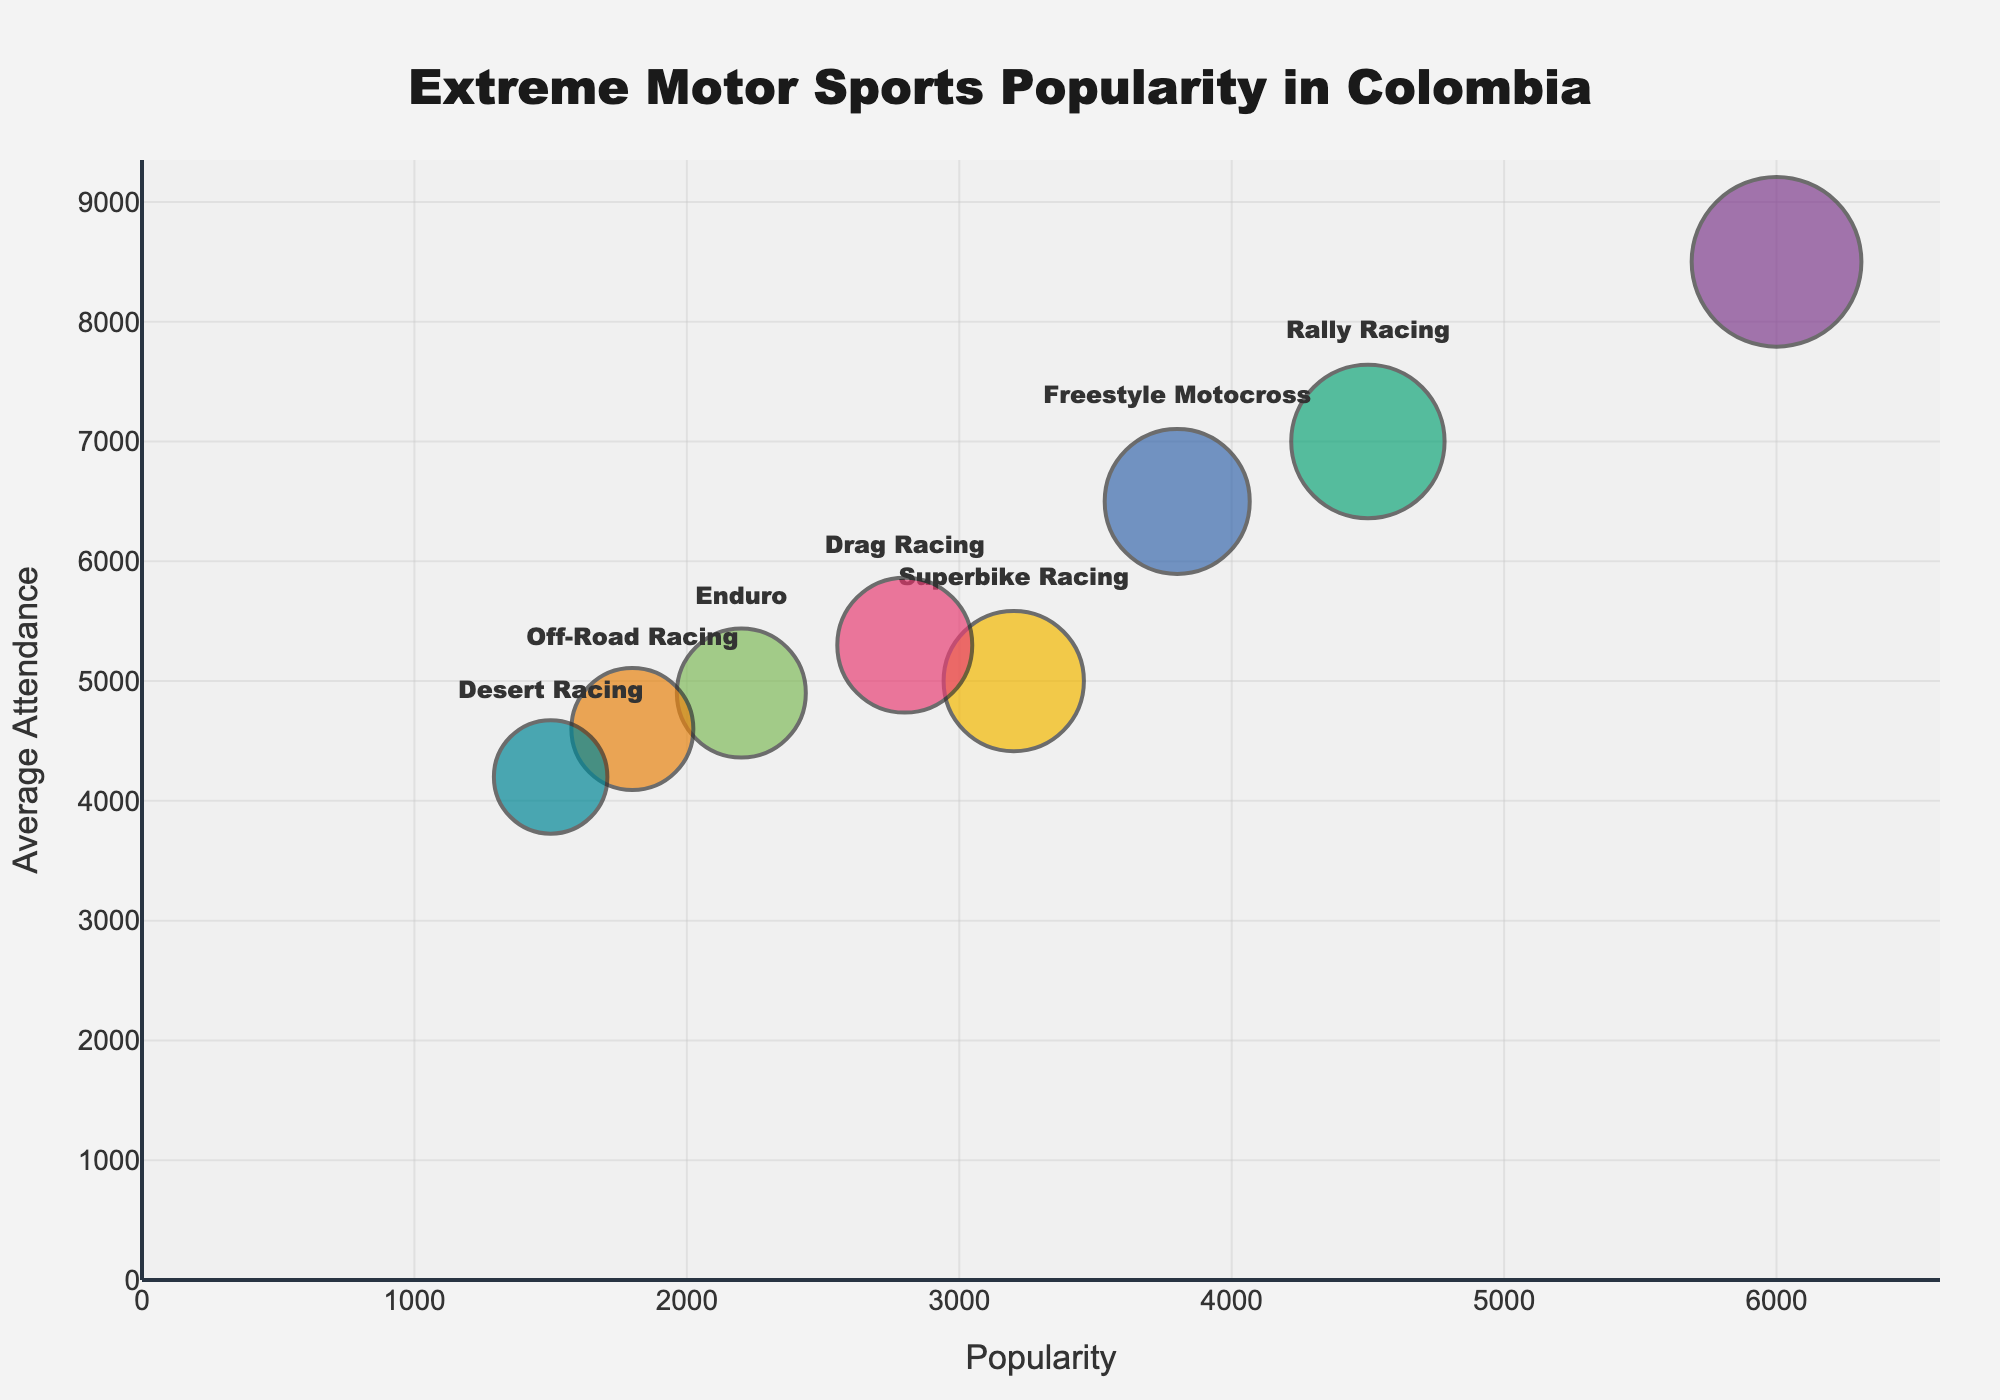What is the title of the Bubble Chart? The title of the Bubble Chart is displayed prominently at the top center of the figure. It reads "Extreme Motor Sports Popularity in Colombia".
Answer: Extreme Motor Sports Popularity in Colombia Which motorsport in Bogota has the highest popularity? The figure shows that the motorsport in Bogota with the highest popularity is "Motocross". You can find this information by looking at the "Region" labels and observing the corresponding "Motorsport" label near the top right of the chart.
Answer: Motocross How many events are conducted for Drag Racing in Cartagena? The bubble size in the chart relates to the number of events. For Drag Racing in Cartagena, the size of the bubble can be traced to the "EventCount" which is represented as 6 within provided data.
Answer: 6 What is the average attendance for Superbike Racing in Barranquilla? The average attendance for Superbike Racing in Barranquilla can be determined by looking at its bubble's position on the y-axis. It falls at the 5000 mark.
Answer: 5000 Which motorsport has the lowest popularity, and what is its corresponding average attendance? The motorsport with the lowest popularity is indicated by the furthest left bubble. This is Desert Racing in Manizales, which has a popularity rating of 1500 and an average attendance of 4200.
Answer: Desert Racing, 4200 Compare the popularity of Freestyle Motocross in Cali with Rally Racing in Medellin. Which is more popular? To compare, look at the x-axis positions of the bubbles for Freestyle Motocross in Cali and Rally Racing in Medellin. Freestyle Motocross in Cali has a popularity of 3800, whereas Rally Racing in Medellin has a popularity of 4500. Rally Racing in Medellin is more popular.
Answer: Rally Racing in Medellin Which region hosts the most events for extreme motor sports? The size of the bubble represents the number of events. By observing the largest bubble, it is clear that Bogota, which hosts Motocross, has the most events, with 15 events.
Answer: Bogota What is the difference in average attendance between Drag Racing in Cartagena and Enduro in Bucaramanga? Drag Racing in Cartagena has an average attendance of 5300, whereas Enduro in Bucaramanga has an average attendance of 4900. The difference is 5300 - 4900 = 400.
Answer: 400 Which motorsport has the highest average attendance, and in which region is it located? By finding the highest point on the y-axis, the highest average attendance is 8500, which corresponds to Motocross in Bogota.
Answer: Motocross, Bogota 